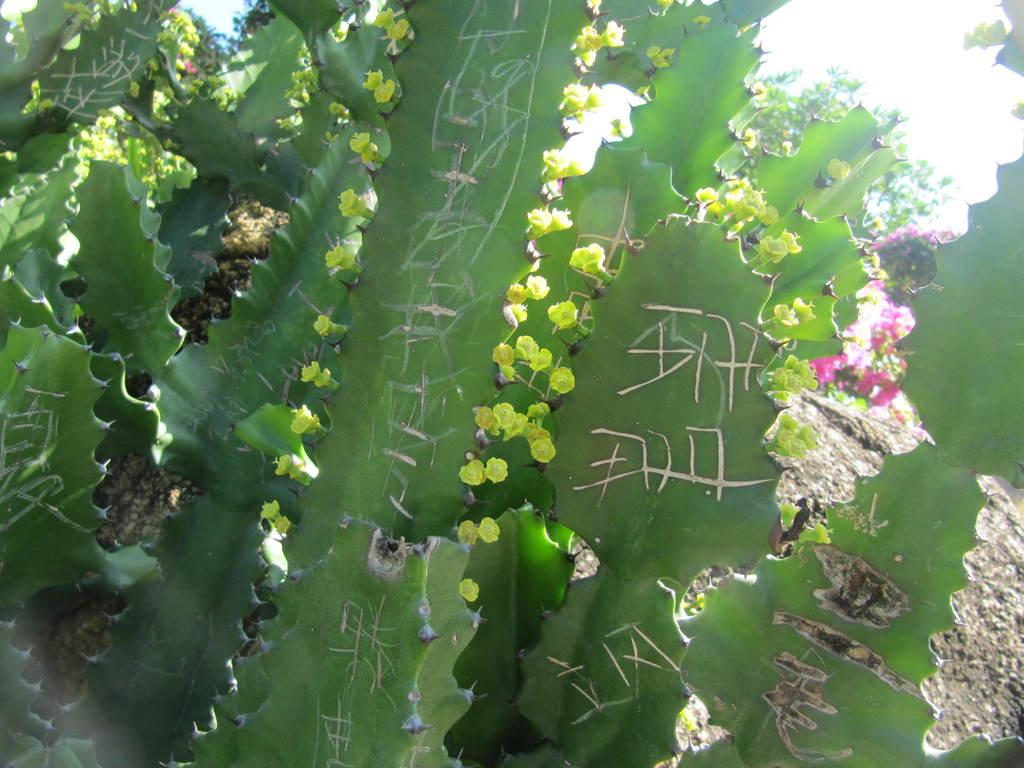What type of plants are in the image? There are cactus plants in the image. Do the cactus plants have any additional features? Yes, the cactus plants have flowers. Can you tell me how many times the cactus plants have been bitten in the image? There is no indication in the image that the cactus plants have been bitten, and therefore no such information can be provided. 